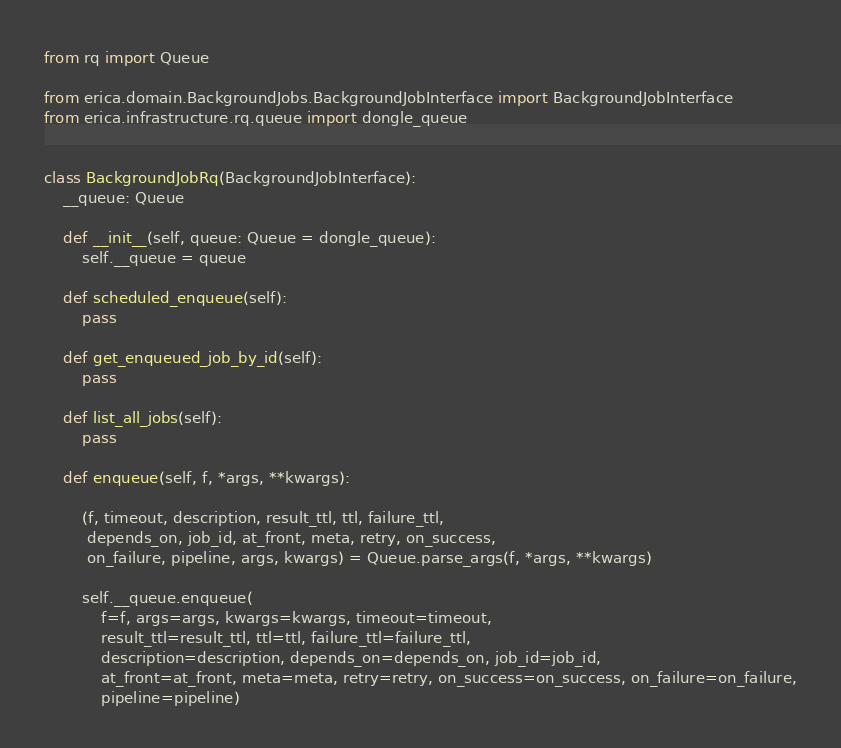<code> <loc_0><loc_0><loc_500><loc_500><_Python_>from rq import Queue

from erica.domain.BackgroundJobs.BackgroundJobInterface import BackgroundJobInterface
from erica.infrastructure.rq.queue import dongle_queue


class BackgroundJobRq(BackgroundJobInterface):
    __queue: Queue

    def __init__(self, queue: Queue = dongle_queue):
        self.__queue = queue

    def scheduled_enqueue(self):
        pass

    def get_enqueued_job_by_id(self):
        pass

    def list_all_jobs(self):
        pass

    def enqueue(self, f, *args, **kwargs):

        (f, timeout, description, result_ttl, ttl, failure_ttl,
         depends_on, job_id, at_front, meta, retry, on_success,
         on_failure, pipeline, args, kwargs) = Queue.parse_args(f, *args, **kwargs)

        self.__queue.enqueue(
            f=f, args=args, kwargs=kwargs, timeout=timeout,
            result_ttl=result_ttl, ttl=ttl, failure_ttl=failure_ttl,
            description=description, depends_on=depends_on, job_id=job_id,
            at_front=at_front, meta=meta, retry=retry, on_success=on_success, on_failure=on_failure,
            pipeline=pipeline)
</code> 